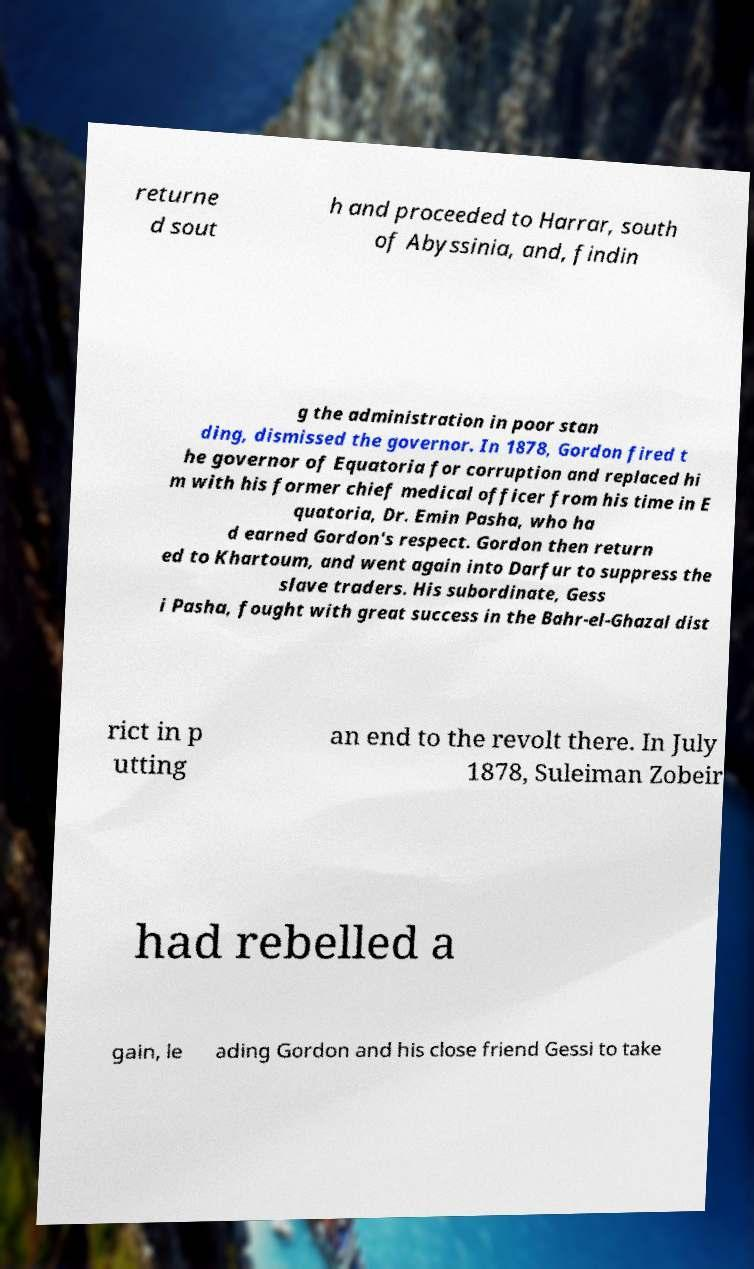There's text embedded in this image that I need extracted. Can you transcribe it verbatim? returne d sout h and proceeded to Harrar, south of Abyssinia, and, findin g the administration in poor stan ding, dismissed the governor. In 1878, Gordon fired t he governor of Equatoria for corruption and replaced hi m with his former chief medical officer from his time in E quatoria, Dr. Emin Pasha, who ha d earned Gordon's respect. Gordon then return ed to Khartoum, and went again into Darfur to suppress the slave traders. His subordinate, Gess i Pasha, fought with great success in the Bahr-el-Ghazal dist rict in p utting an end to the revolt there. In July 1878, Suleiman Zobeir had rebelled a gain, le ading Gordon and his close friend Gessi to take 